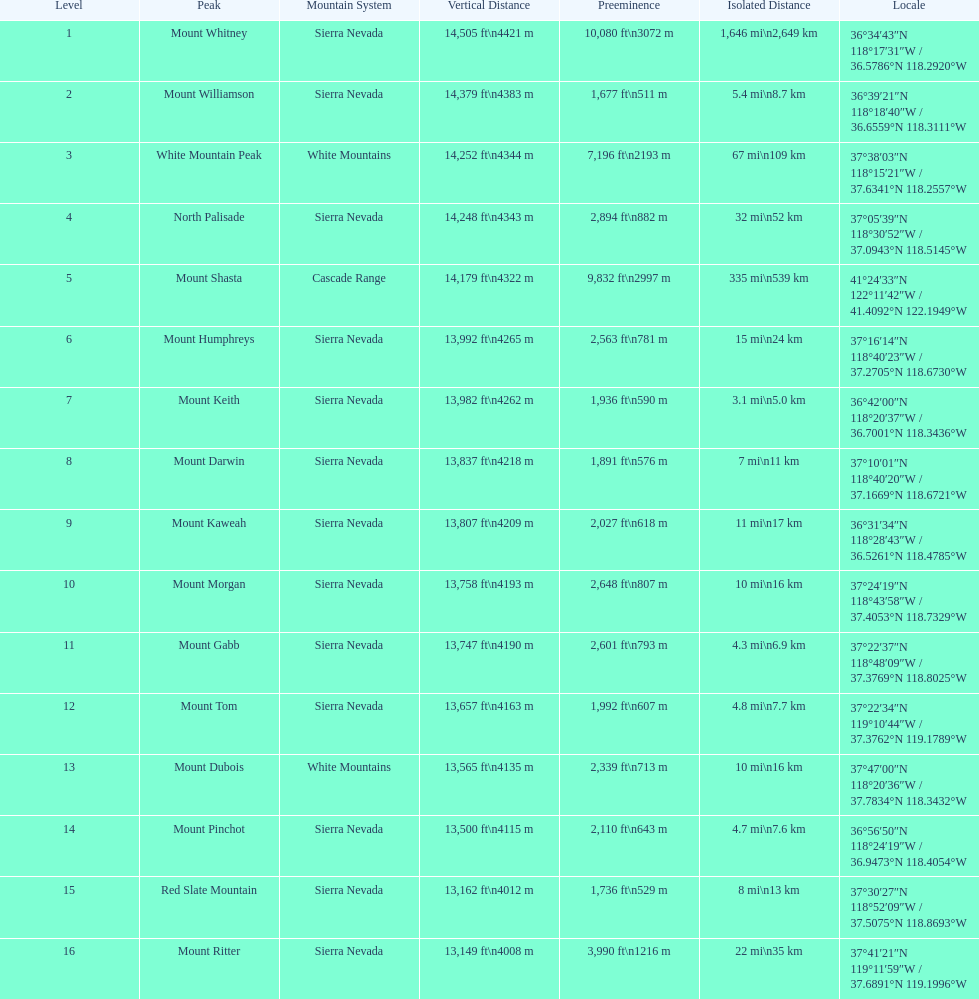What is the cumulative elevation (in ft) of mount whitney? 14,505 ft. 